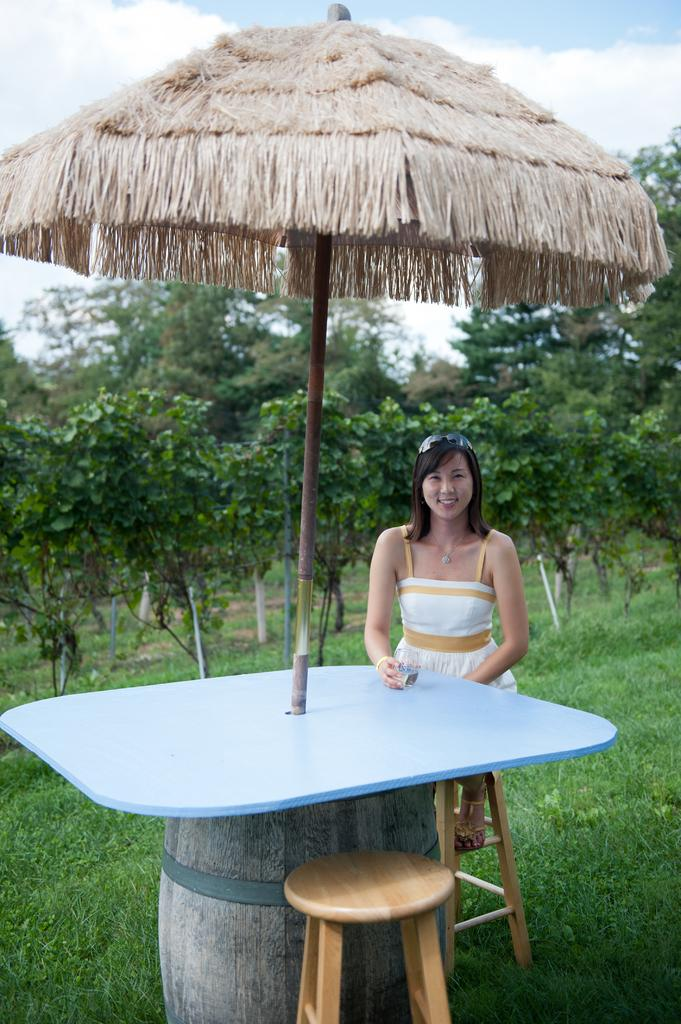Who is present in the image? There is a woman in the image. What is in front of the woman? There is a table with an umbrella in front of the woman. What type of vegetation can be seen in the image? There are trees visible in the image. What is the color of the grass in the image? The grass is green in color. What letter is written on the clover in the image? There is no clover present in the image, and therefore no letter can be found on it. 